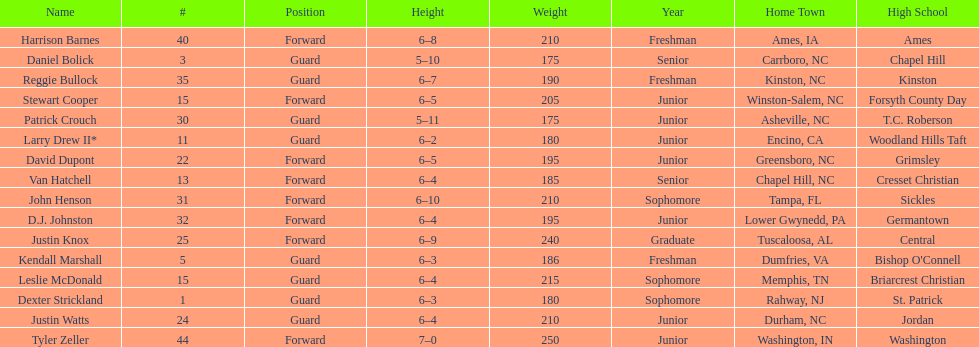What was the number of players with a height greater than van hatchell? 7. 